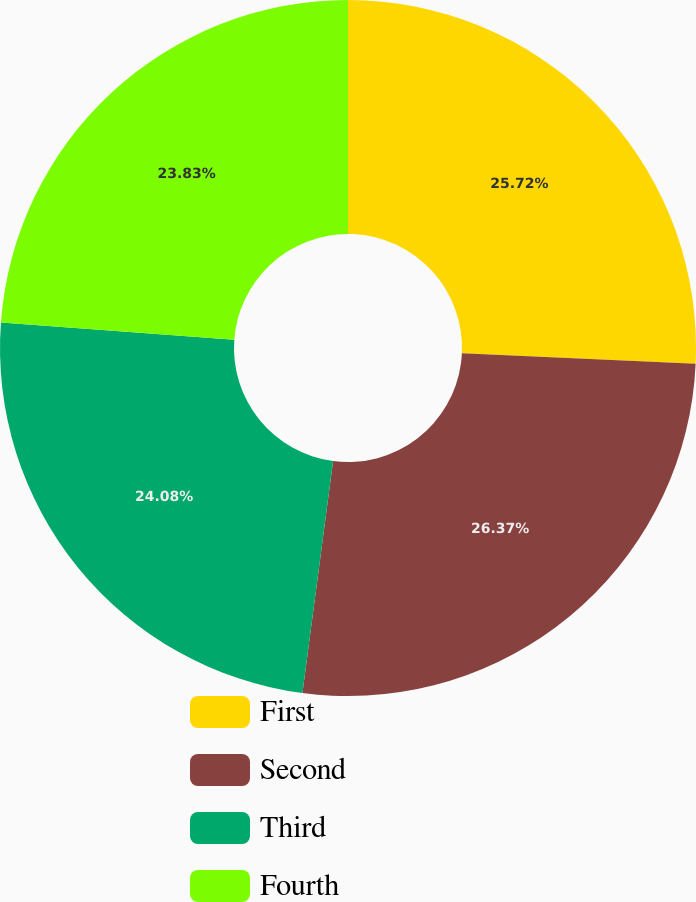Convert chart to OTSL. <chart><loc_0><loc_0><loc_500><loc_500><pie_chart><fcel>First<fcel>Second<fcel>Third<fcel>Fourth<nl><fcel>25.72%<fcel>26.37%<fcel>24.08%<fcel>23.83%<nl></chart> 